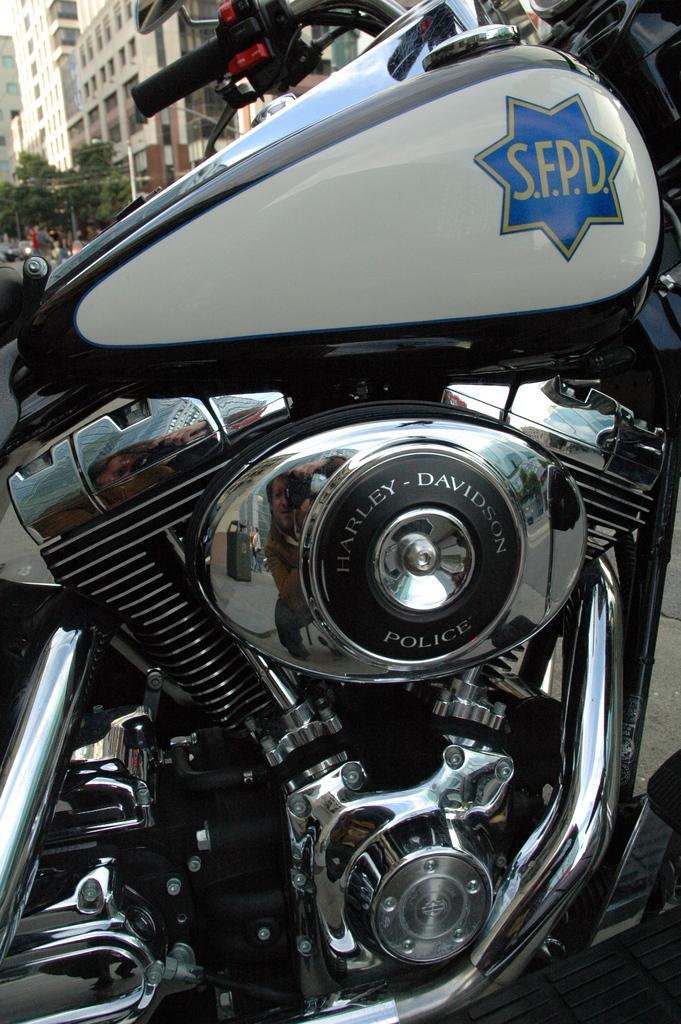Could you give a brief overview of what you see in this image? In this picture we see a bike made of steel and iron, behind which we have buildings and trees. 